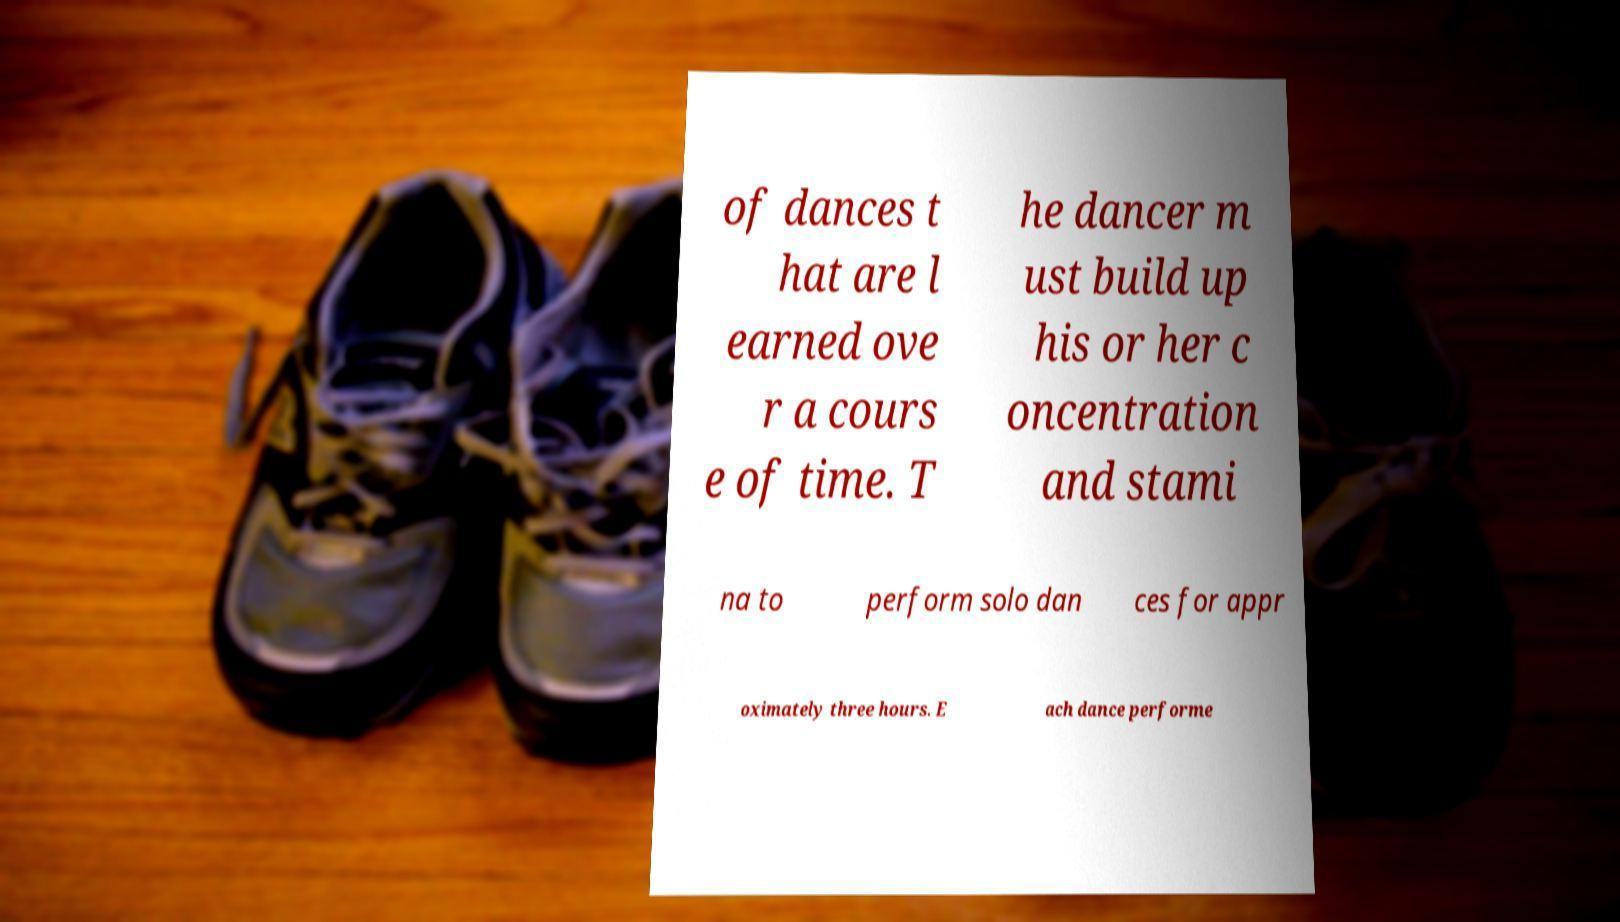I need the written content from this picture converted into text. Can you do that? of dances t hat are l earned ove r a cours e of time. T he dancer m ust build up his or her c oncentration and stami na to perform solo dan ces for appr oximately three hours. E ach dance performe 